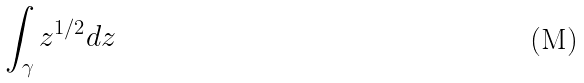<formula> <loc_0><loc_0><loc_500><loc_500>\int _ { \gamma } z ^ { 1 / 2 } d z</formula> 